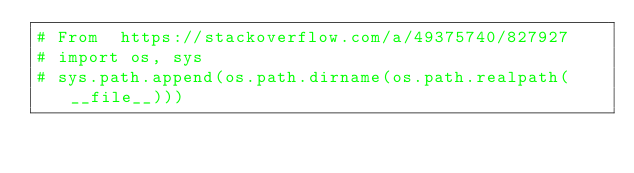<code> <loc_0><loc_0><loc_500><loc_500><_Python_># From  https://stackoverflow.com/a/49375740/827927
# import os, sys
# sys.path.append(os.path.dirname(os.path.realpath(__file__)))
</code> 